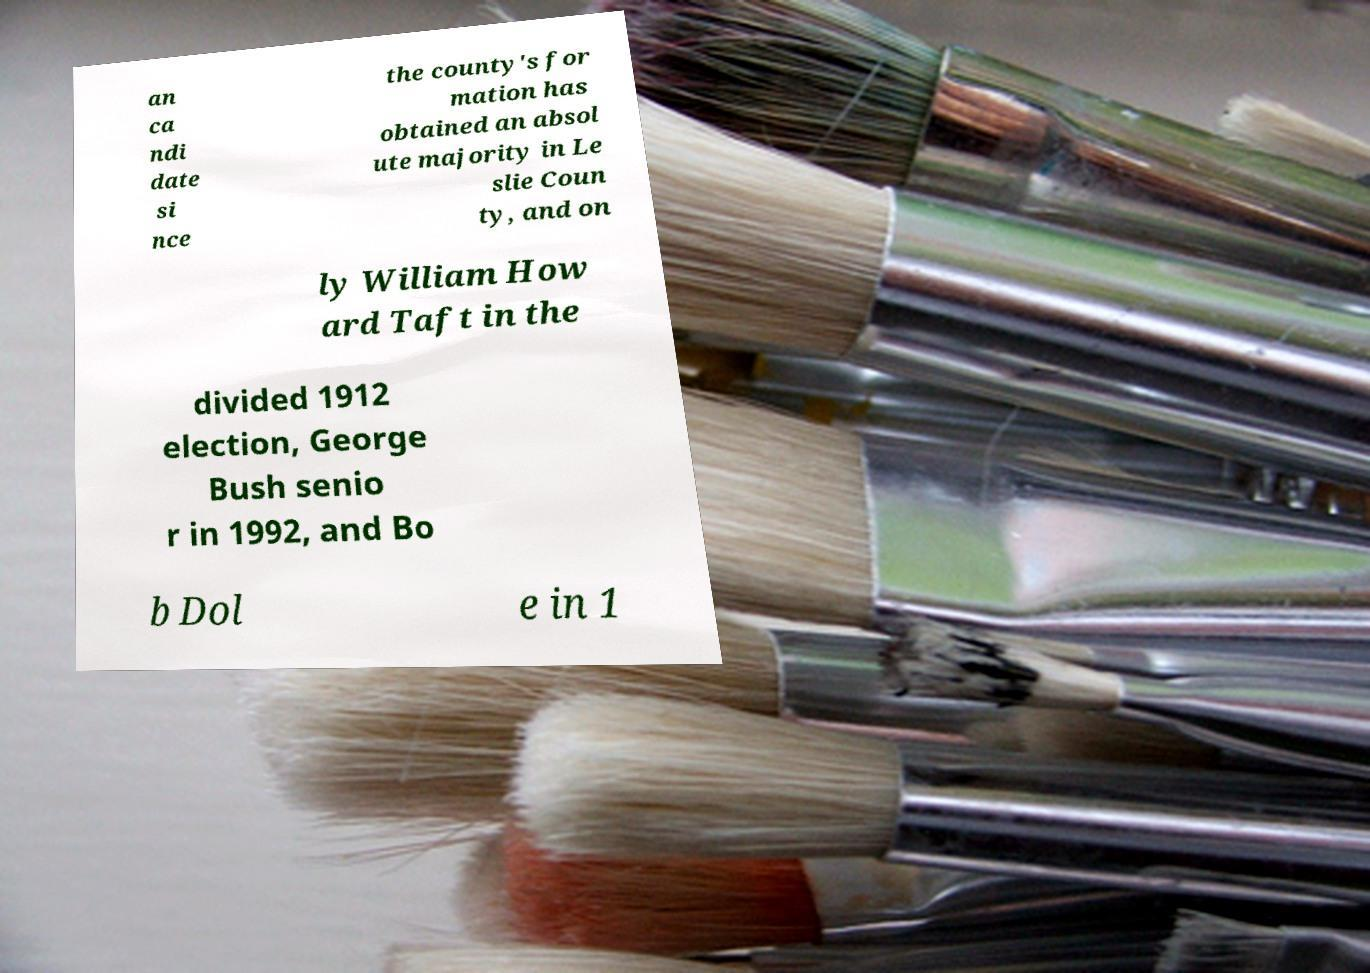Could you assist in decoding the text presented in this image and type it out clearly? an ca ndi date si nce the county's for mation has obtained an absol ute majority in Le slie Coun ty, and on ly William How ard Taft in the divided 1912 election, George Bush senio r in 1992, and Bo b Dol e in 1 